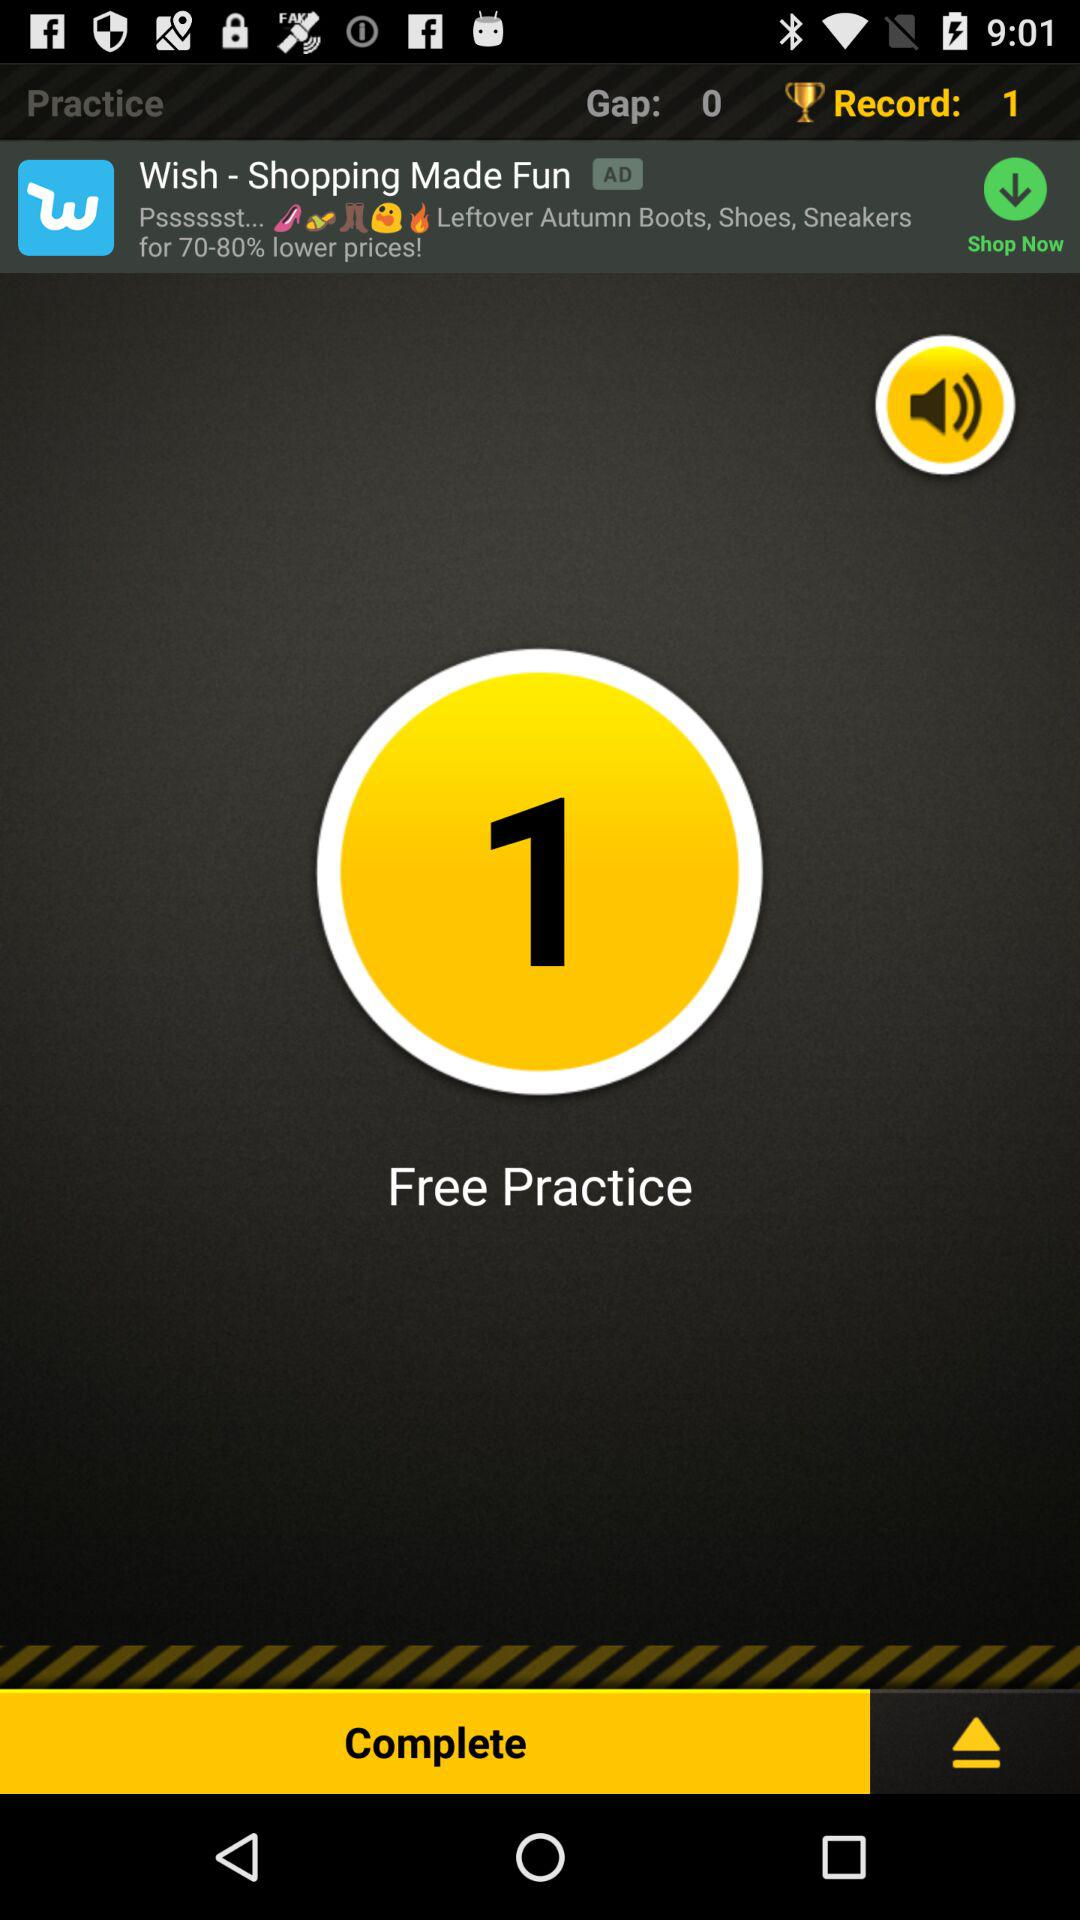What is the difference between the gap and record values?
Answer the question using a single word or phrase. 1 